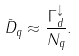Convert formula to latex. <formula><loc_0><loc_0><loc_500><loc_500>\bar { D } _ { q } \approx \frac { \Gamma ^ { \downarrow } _ { d } } { N _ { q } } .</formula> 